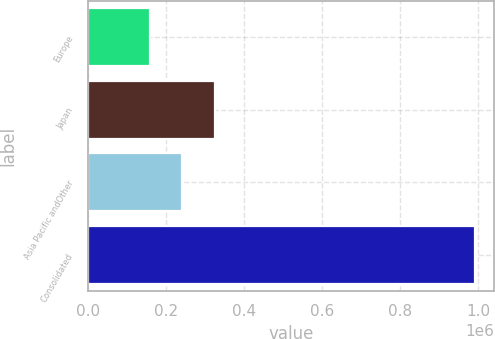Convert chart. <chart><loc_0><loc_0><loc_500><loc_500><bar_chart><fcel>Europe<fcel>Japan<fcel>Asia Pacific andOther<fcel>Consolidated<nl><fcel>157468<fcel>324361<fcel>240914<fcel>991931<nl></chart> 